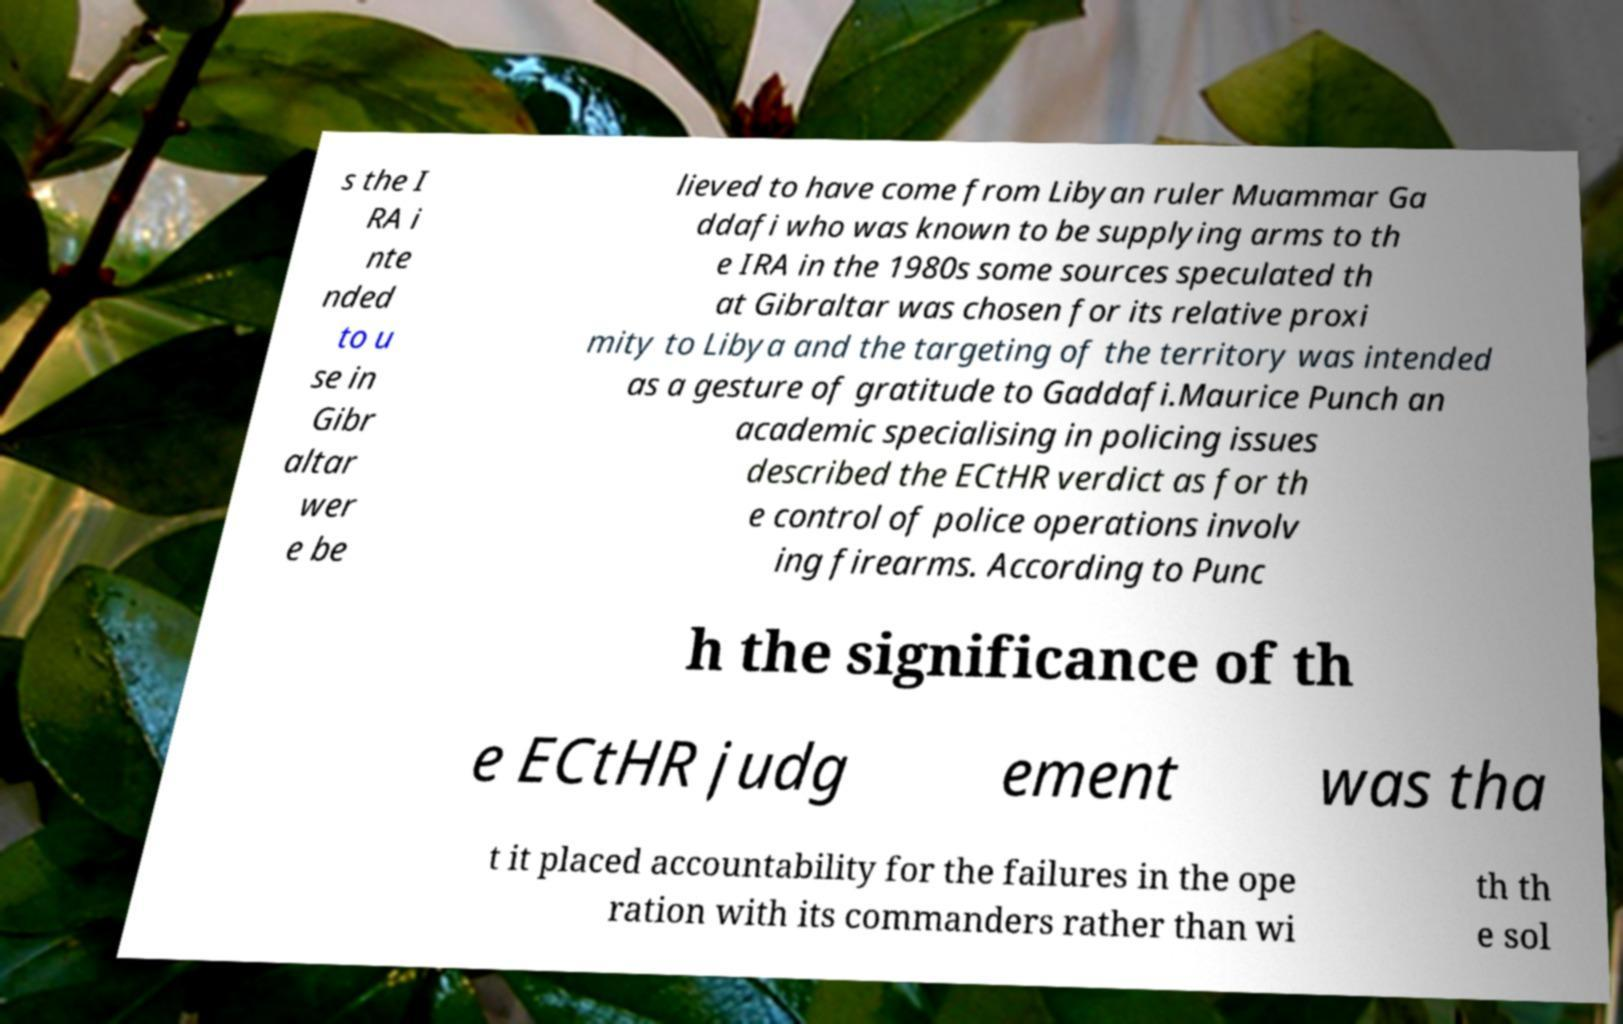For documentation purposes, I need the text within this image transcribed. Could you provide that? s the I RA i nte nded to u se in Gibr altar wer e be lieved to have come from Libyan ruler Muammar Ga ddafi who was known to be supplying arms to th e IRA in the 1980s some sources speculated th at Gibraltar was chosen for its relative proxi mity to Libya and the targeting of the territory was intended as a gesture of gratitude to Gaddafi.Maurice Punch an academic specialising in policing issues described the ECtHR verdict as for th e control of police operations involv ing firearms. According to Punc h the significance of th e ECtHR judg ement was tha t it placed accountability for the failures in the ope ration with its commanders rather than wi th th e sol 